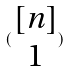Convert formula to latex. <formula><loc_0><loc_0><loc_500><loc_500>( \begin{matrix} [ n ] \\ 1 \end{matrix} )</formula> 